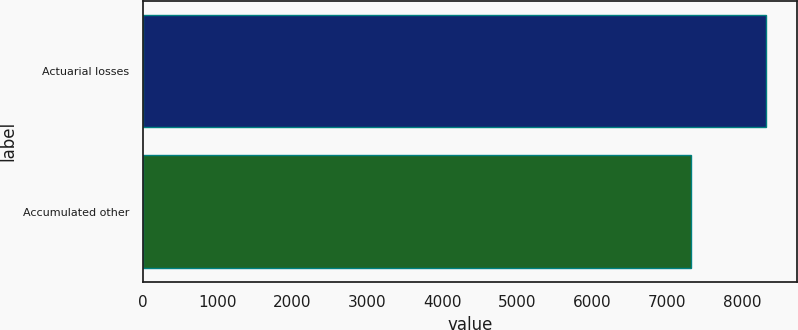<chart> <loc_0><loc_0><loc_500><loc_500><bar_chart><fcel>Actuarial losses<fcel>Accumulated other<nl><fcel>8321<fcel>7321<nl></chart> 